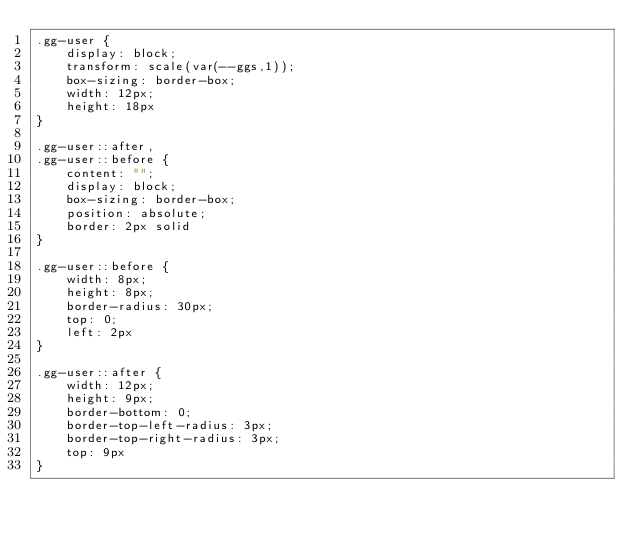<code> <loc_0><loc_0><loc_500><loc_500><_CSS_>.gg-user {
    display: block;
    transform: scale(var(--ggs,1));
    box-sizing: border-box;
    width: 12px;
    height: 18px
}

.gg-user::after,
.gg-user::before {
    content: "";
    display: block;
    box-sizing: border-box;
    position: absolute;
    border: 2px solid
}

.gg-user::before {
    width: 8px;
    height: 8px;
    border-radius: 30px;
    top: 0;
    left: 2px
}

.gg-user::after {
    width: 12px;
    height: 9px;
    border-bottom: 0;
    border-top-left-radius: 3px;
    border-top-right-radius: 3px;
    top: 9px
}</code> 